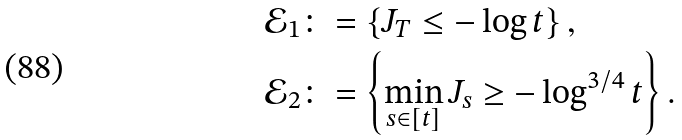Convert formula to latex. <formula><loc_0><loc_0><loc_500><loc_500>\mathcal { E } _ { 1 } & \colon = \left \{ J _ { T } \leq - \log t \right \} , \\ \mathcal { E } _ { 2 } & \colon = \left \{ \min _ { s \in \left [ t \right ] } J _ { s } \geq - \log ^ { 3 / 4 } t \right \} .</formula> 